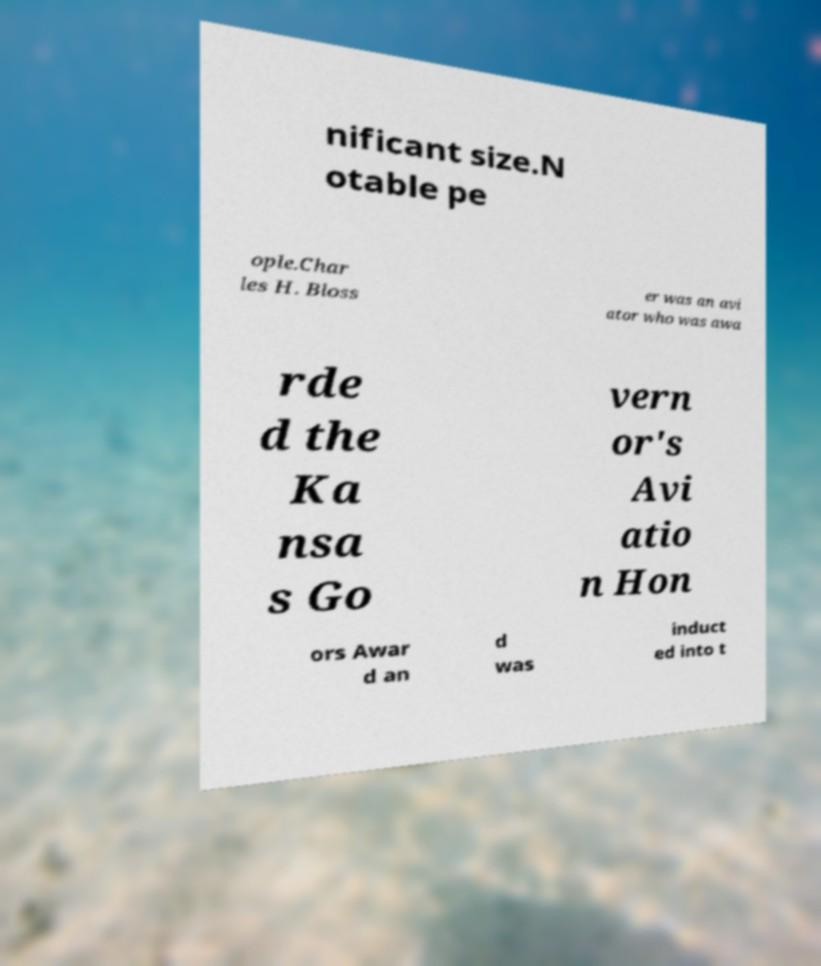Please identify and transcribe the text found in this image. nificant size.N otable pe ople.Char les H. Bloss er was an avi ator who was awa rde d the Ka nsa s Go vern or's Avi atio n Hon ors Awar d an d was induct ed into t 